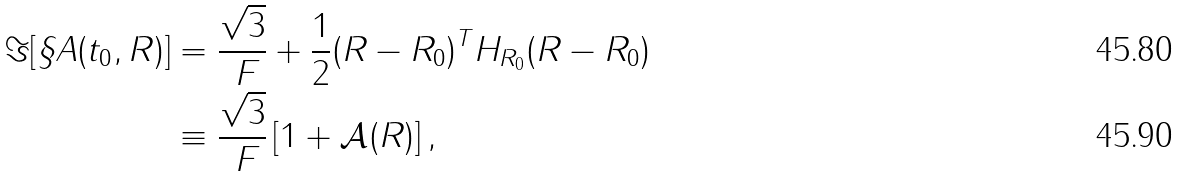Convert formula to latex. <formula><loc_0><loc_0><loc_500><loc_500>\Im [ \S A ( t _ { 0 } , R ) ] & = \frac { \sqrt { 3 } } { \ F } + \frac { 1 } { 2 } ( R - R _ { 0 } ) ^ { T } H _ { R _ { 0 } } ( R - R _ { 0 } ) \\ & \equiv \frac { \sqrt { 3 } } { \ F } \left [ 1 + \mathcal { A } ( R ) \right ] ,</formula> 